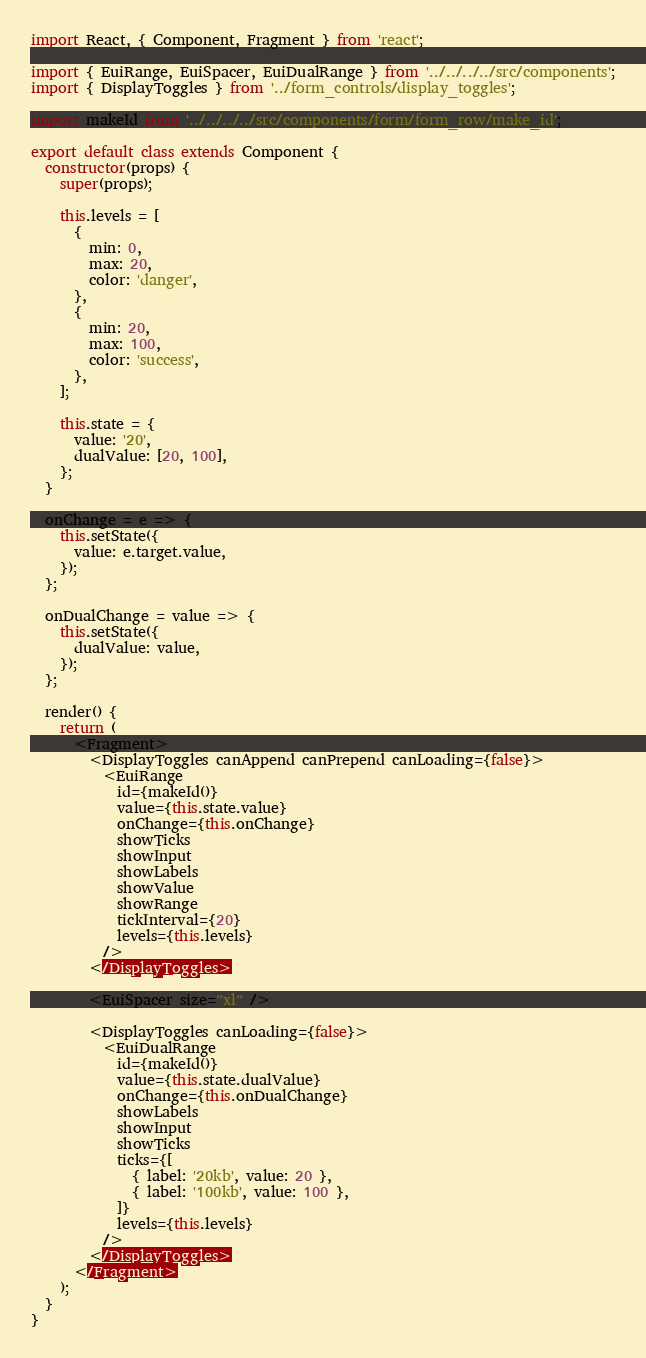<code> <loc_0><loc_0><loc_500><loc_500><_JavaScript_>import React, { Component, Fragment } from 'react';

import { EuiRange, EuiSpacer, EuiDualRange } from '../../../../src/components';
import { DisplayToggles } from '../form_controls/display_toggles';

import makeId from '../../../../src/components/form/form_row/make_id';

export default class extends Component {
  constructor(props) {
    super(props);

    this.levels = [
      {
        min: 0,
        max: 20,
        color: 'danger',
      },
      {
        min: 20,
        max: 100,
        color: 'success',
      },
    ];

    this.state = {
      value: '20',
      dualValue: [20, 100],
    };
  }

  onChange = e => {
    this.setState({
      value: e.target.value,
    });
  };

  onDualChange = value => {
    this.setState({
      dualValue: value,
    });
  };

  render() {
    return (
      <Fragment>
        <DisplayToggles canAppend canPrepend canLoading={false}>
          <EuiRange
            id={makeId()}
            value={this.state.value}
            onChange={this.onChange}
            showTicks
            showInput
            showLabels
            showValue
            showRange
            tickInterval={20}
            levels={this.levels}
          />
        </DisplayToggles>

        <EuiSpacer size="xl" />

        <DisplayToggles canLoading={false}>
          <EuiDualRange
            id={makeId()}
            value={this.state.dualValue}
            onChange={this.onDualChange}
            showLabels
            showInput
            showTicks
            ticks={[
              { label: '20kb', value: 20 },
              { label: '100kb', value: 100 },
            ]}
            levels={this.levels}
          />
        </DisplayToggles>
      </Fragment>
    );
  }
}
</code> 